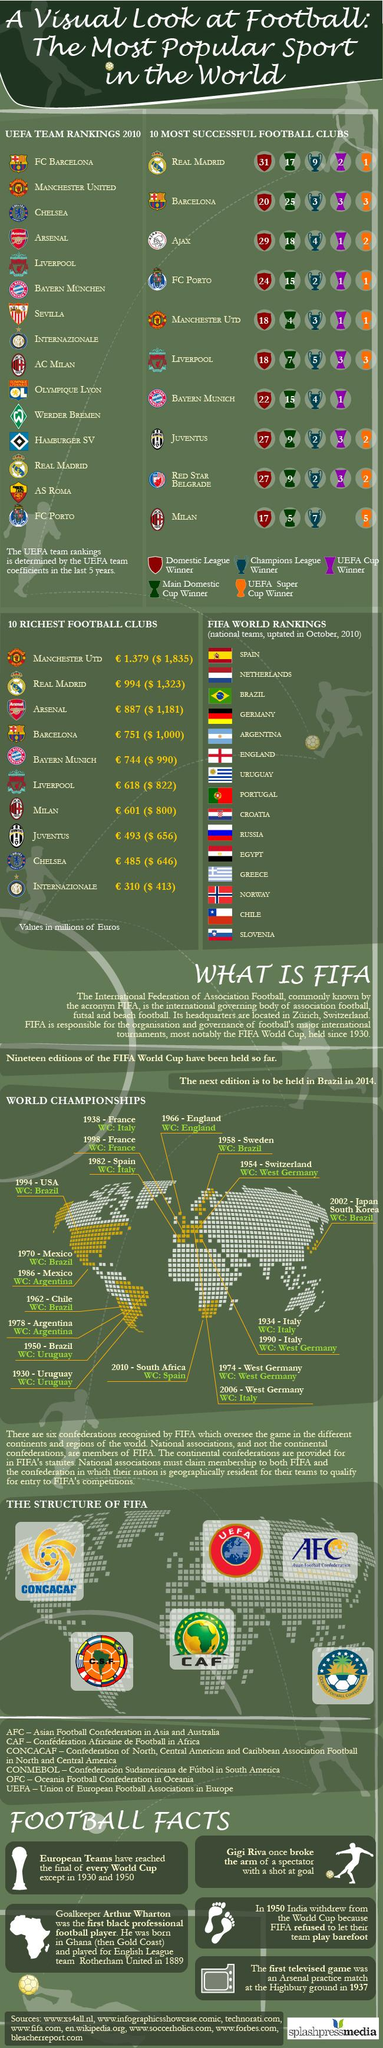Identify some key points in this picture. There are 15 country flags displayed. The football clubs of INTERNAZIONALE, CHELSEA, and JUVENTUS are the three richest clubs from the bottom, boasting impressive financial standings in the sport. 